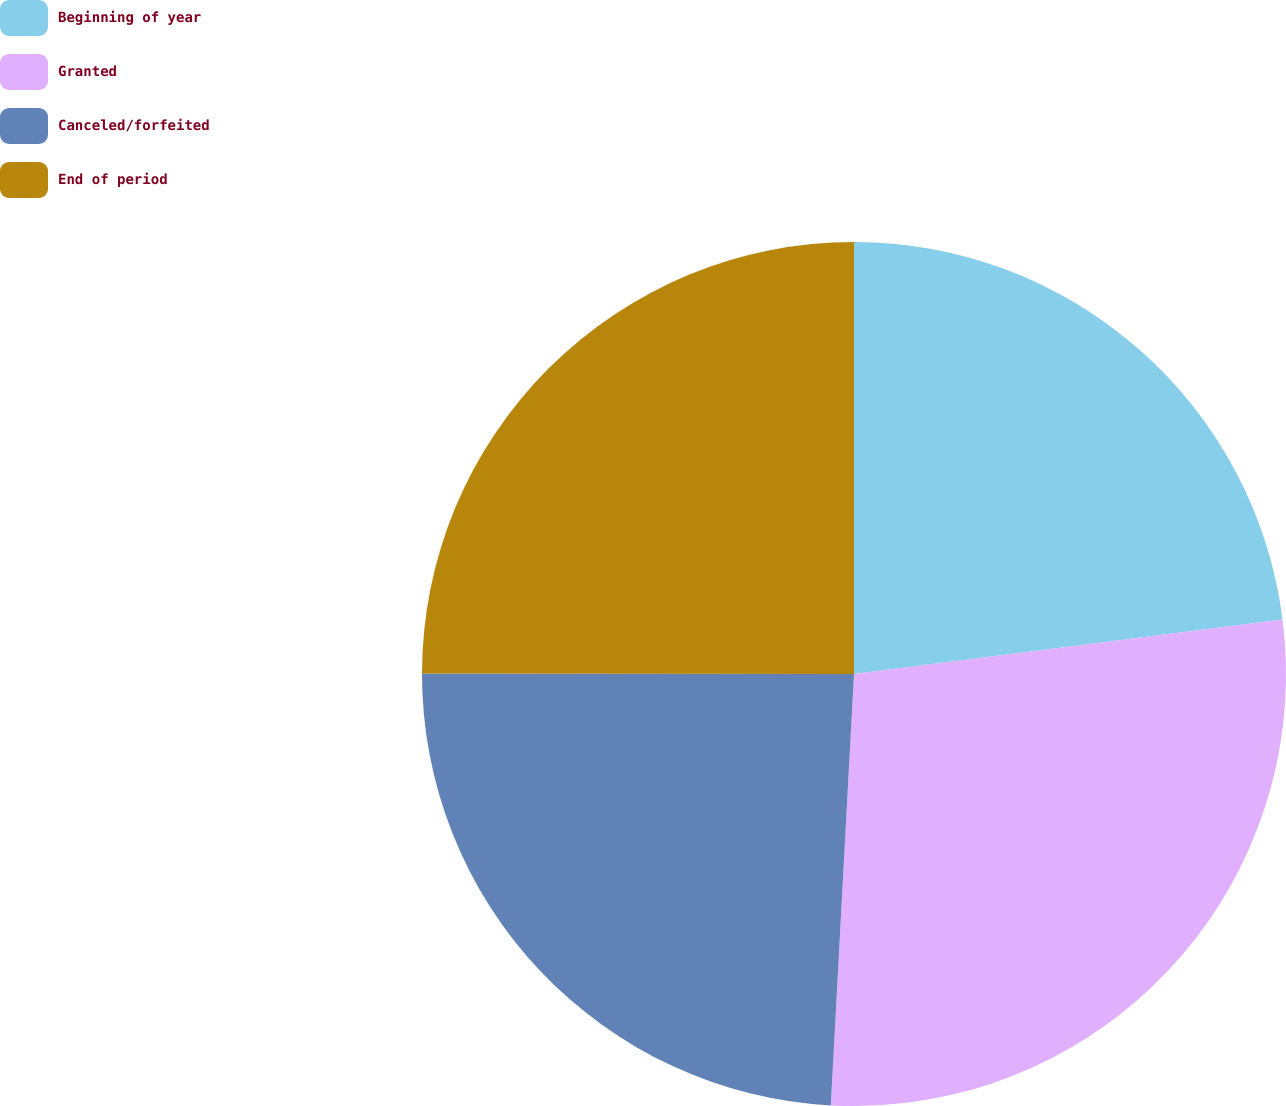Convert chart. <chart><loc_0><loc_0><loc_500><loc_500><pie_chart><fcel>Beginning of year<fcel>Granted<fcel>Canceled/forfeited<fcel>End of period<nl><fcel>22.98%<fcel>27.87%<fcel>24.16%<fcel>24.98%<nl></chart> 